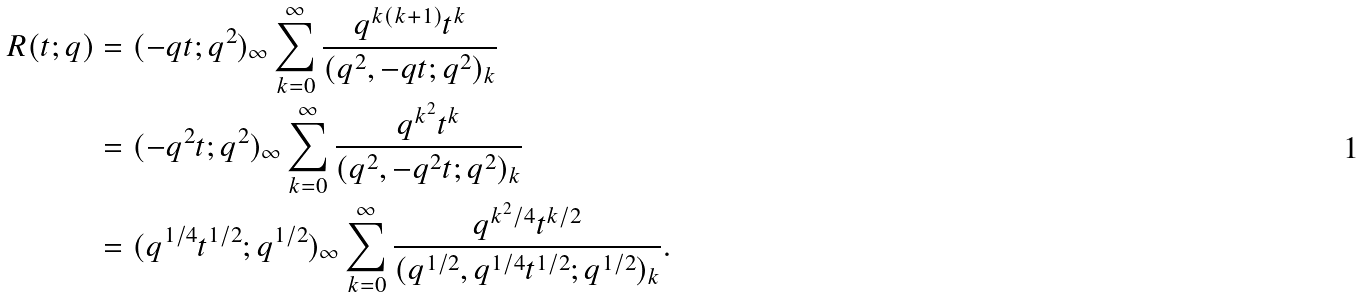Convert formula to latex. <formula><loc_0><loc_0><loc_500><loc_500>R ( t ; q ) & = ( - q t ; q ^ { 2 } ) _ { \infty } \sum _ { k = 0 } ^ { \infty } \frac { q ^ { k ( k + 1 ) } t ^ { k } } { ( q ^ { 2 } , - q t ; q ^ { 2 } ) _ { k } } \\ & = ( - q ^ { 2 } t ; q ^ { 2 } ) _ { \infty } \sum _ { k = 0 } ^ { \infty } \frac { q ^ { k ^ { 2 } } t ^ { k } } { ( q ^ { 2 } , - q ^ { 2 } t ; q ^ { 2 } ) _ { k } } \\ & = ( q ^ { 1 / 4 } t ^ { 1 / 2 } ; q ^ { 1 / 2 } ) _ { \infty } \sum _ { k = 0 } ^ { \infty } \frac { q ^ { k ^ { 2 } / 4 } t ^ { k / 2 } } { ( q ^ { 1 / 2 } , q ^ { 1 / 4 } t ^ { 1 / 2 } ; q ^ { 1 / 2 } ) _ { k } } .</formula> 